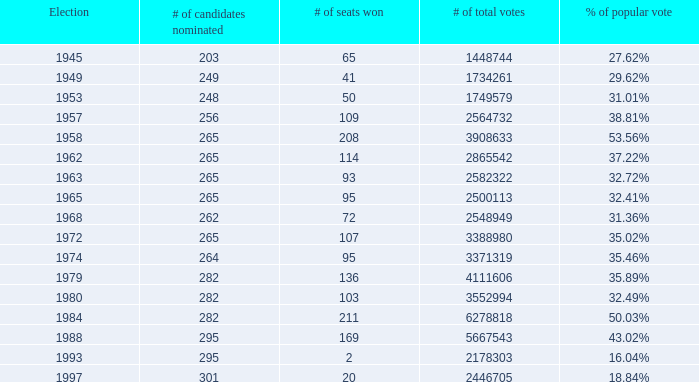What year was the election when the # of seats won was 65? 1945.0. Parse the table in full. {'header': ['Election', '# of candidates nominated', '# of seats won', '# of total votes', '% of popular vote'], 'rows': [['1945', '203', '65', '1448744', '27.62%'], ['1949', '249', '41', '1734261', '29.62%'], ['1953', '248', '50', '1749579', '31.01%'], ['1957', '256', '109', '2564732', '38.81%'], ['1958', '265', '208', '3908633', '53.56%'], ['1962', '265', '114', '2865542', '37.22%'], ['1963', '265', '93', '2582322', '32.72%'], ['1965', '265', '95', '2500113', '32.41%'], ['1968', '262', '72', '2548949', '31.36%'], ['1972', '265', '107', '3388980', '35.02%'], ['1974', '264', '95', '3371319', '35.46%'], ['1979', '282', '136', '4111606', '35.89%'], ['1980', '282', '103', '3552994', '32.49%'], ['1984', '282', '211', '6278818', '50.03%'], ['1988', '295', '169', '5667543', '43.02%'], ['1993', '295', '2', '2178303', '16.04%'], ['1997', '301', '20', '2446705', '18.84%']]} 